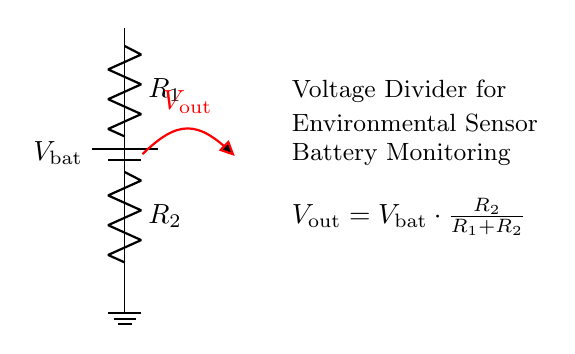What is the purpose of the voltage divider in this circuit? The voltage divider is used to monitor the battery voltage output by providing a scaled-down voltage that can be read by an environmental sensor.
Answer: Battery monitoring What are the names of the two resistors in the circuit? The resistors in this circuit are labeled as R1 and R2, indicating their respective places in the voltage divider configuration.
Answer: R1 and R2 What happens to the output voltage if R2 is increased? Increasing R2 raises the output voltage due to the ratio of R2 to the total resistance (R1 + R2) becoming larger, thereby allowing more of the battery voltage to appear at the output.
Answer: Output voltage increases What is the equation for the output voltage of the voltage divider? The equation is derived from the voltage divider principle which states that the output voltage is the input voltage multiplied by the ratio of R2 to the total resistance (R1 + R2). This gives us the formula: Vout = Vbat * (R2 / (R1 + R2)).
Answer: Vout = Vbat * (R2 / (R1 + R2)) What happens to Vout if R1 is reduced while R2 remains constant? If R1 is reduced and R2 remains constant, the total resistance decreasing results in a larger fraction of the battery voltage being dropped across R2, thus increasing the output voltage Vout.
Answer: Vout increases 